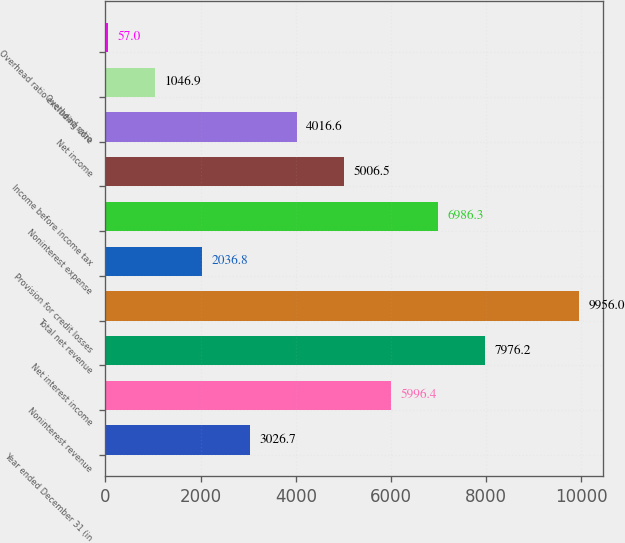<chart> <loc_0><loc_0><loc_500><loc_500><bar_chart><fcel>Year ended December 31 (in<fcel>Noninterest revenue<fcel>Net interest income<fcel>Total net revenue<fcel>Provision for credit losses<fcel>Noninterest expense<fcel>Income before income tax<fcel>Net income<fcel>Overhead ratio<fcel>Overhead ratio excluding core<nl><fcel>3026.7<fcel>5996.4<fcel>7976.2<fcel>9956<fcel>2036.8<fcel>6986.3<fcel>5006.5<fcel>4016.6<fcel>1046.9<fcel>57<nl></chart> 